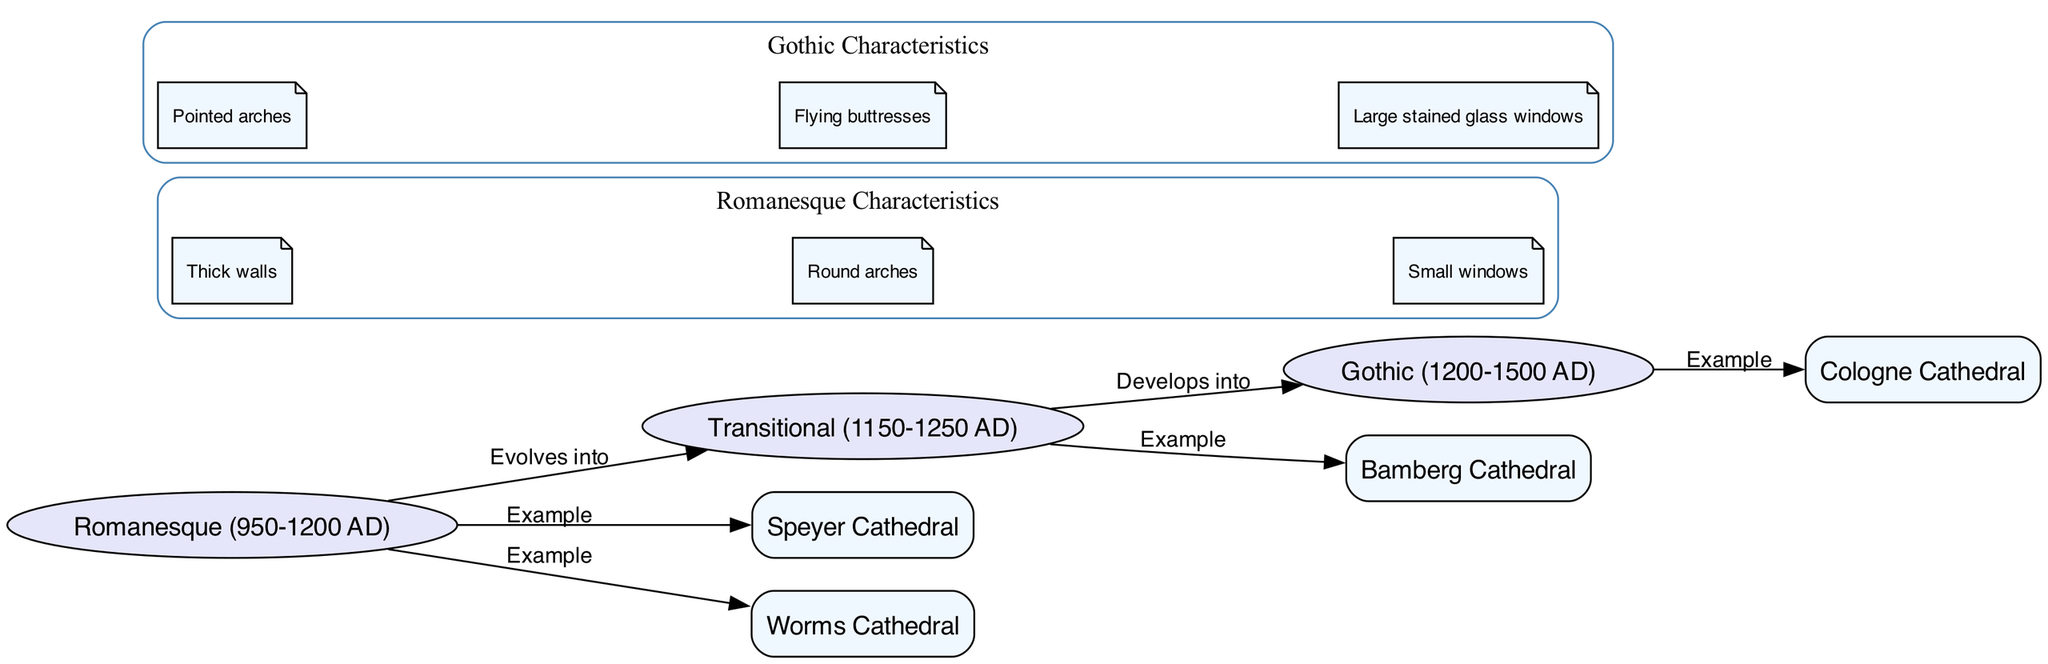What is the earliest architectural period depicted in the diagram? The diagram starts with the Romanesque period, which is specifically labeled as beginning in 950 AD.
Answer: Romanesque (950-1200 AD) How many main architectural periods are represented in the diagram? There are three main architectural periods represented: Romanesque, Transitional, and Gothic.
Answer: 3 Which cathedral is an example from the Romanesque period? The diagram explicitly indicates both Speyer Cathedral and Worms Cathedral as examples of the Romanesque period.
Answer: Speyer Cathedral What architectural feature is common in Gothic cathedrals? The diagram highlights “Pointed arches” as a distinctive architectural feature of Gothic cathedrals.
Answer: Pointed arches How does the Transitional period relate to the Gothic period? The diagram shows that the Transitional period develops into the Gothic period, indicating a progression from one style to the next.
Answer: Develops into How many examples are listed for the Transitional period? The diagram identifies one example from the Transitional period, which is Bamberg Cathedral.
Answer: 1 What do thick walls characterize in the architectural evolution shown? In the diagram, thick walls are attributed to the Romanesque period, which reflects its structural design characteristics.
Answer: Romanesque Which cathedral exemplifies the Gothic style? The diagram lists Cologne Cathedral as an example of the Gothic architectural style.
Answer: Cologne Cathedral What relationship exists between Romanesque and Transitional periods? The diagram specifies that the Romanesque period evolves into the Transitional period, showing a direct relationship in architectural evolution.
Answer: Evolves into 